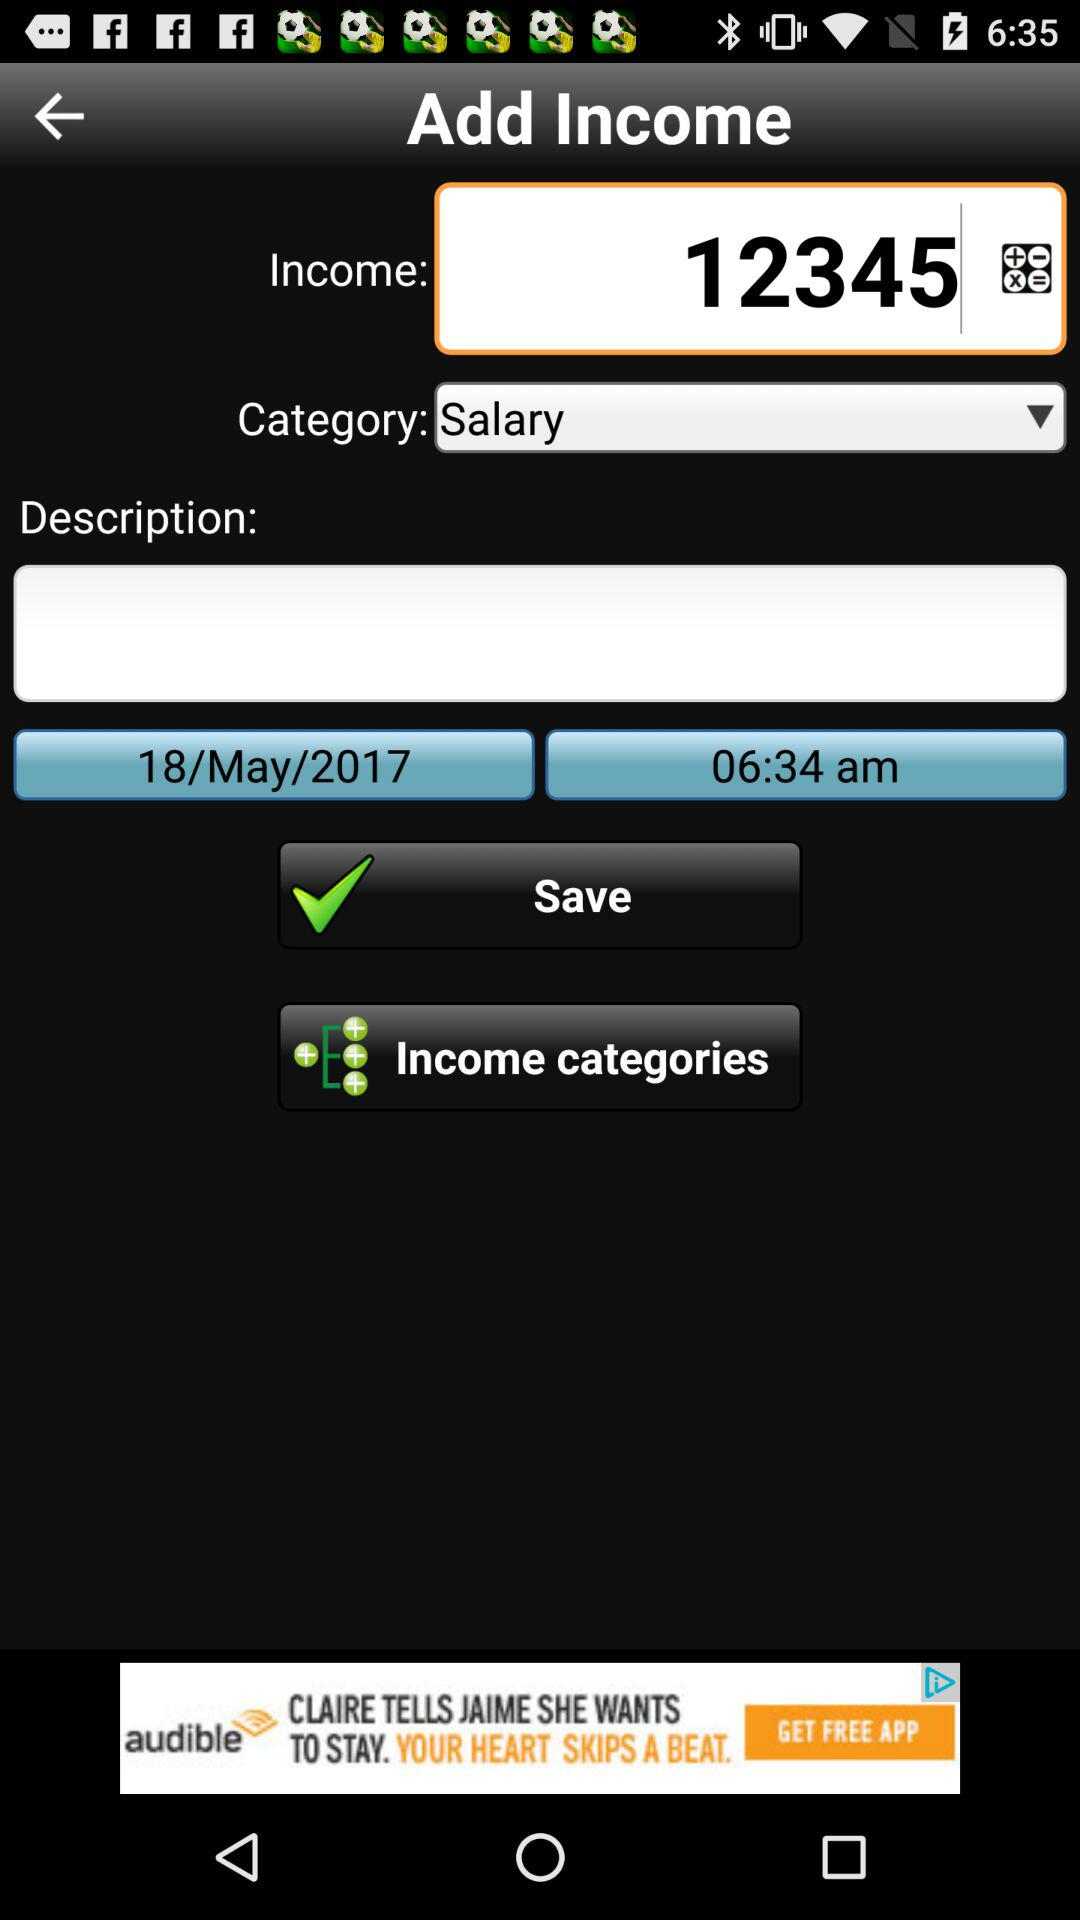What is the date? The date is May 18, 2017. 